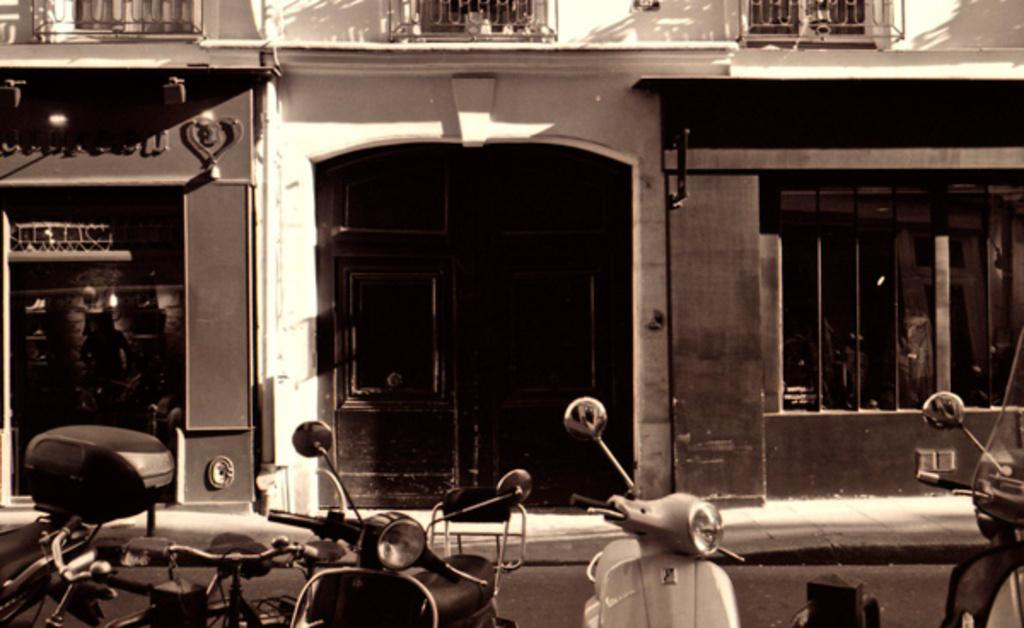What types of vehicles are present in the image? There are bicycles and scooters in the image. What can be seen in the background of the image? There is a building in the background of the image. What features does the building have? The building has windows and doors. What is the color scheme of the image? The image is black and white. How many rods can be seen attached to the scooters in the image? There are no rods attached to the scooters in the image. What type of scale is used to weigh the bicycles in the image? There is no scale present in the image, and the bicycles are not being weighed. 